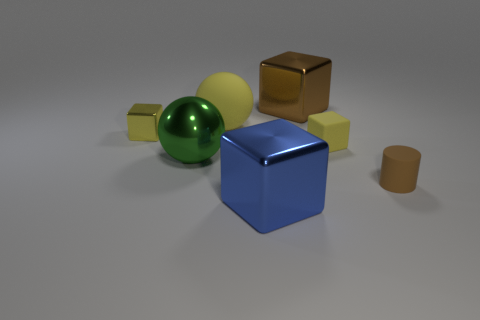Subtract all brown blocks. How many blocks are left? 3 Subtract all brown blocks. How many blocks are left? 3 Subtract all green blocks. Subtract all gray balls. How many blocks are left? 4 Add 1 balls. How many objects exist? 8 Subtract all cylinders. How many objects are left? 6 Add 6 brown rubber cylinders. How many brown rubber cylinders exist? 7 Subtract 1 green balls. How many objects are left? 6 Subtract all small yellow rubber cubes. Subtract all small brown objects. How many objects are left? 5 Add 2 big brown things. How many big brown things are left? 3 